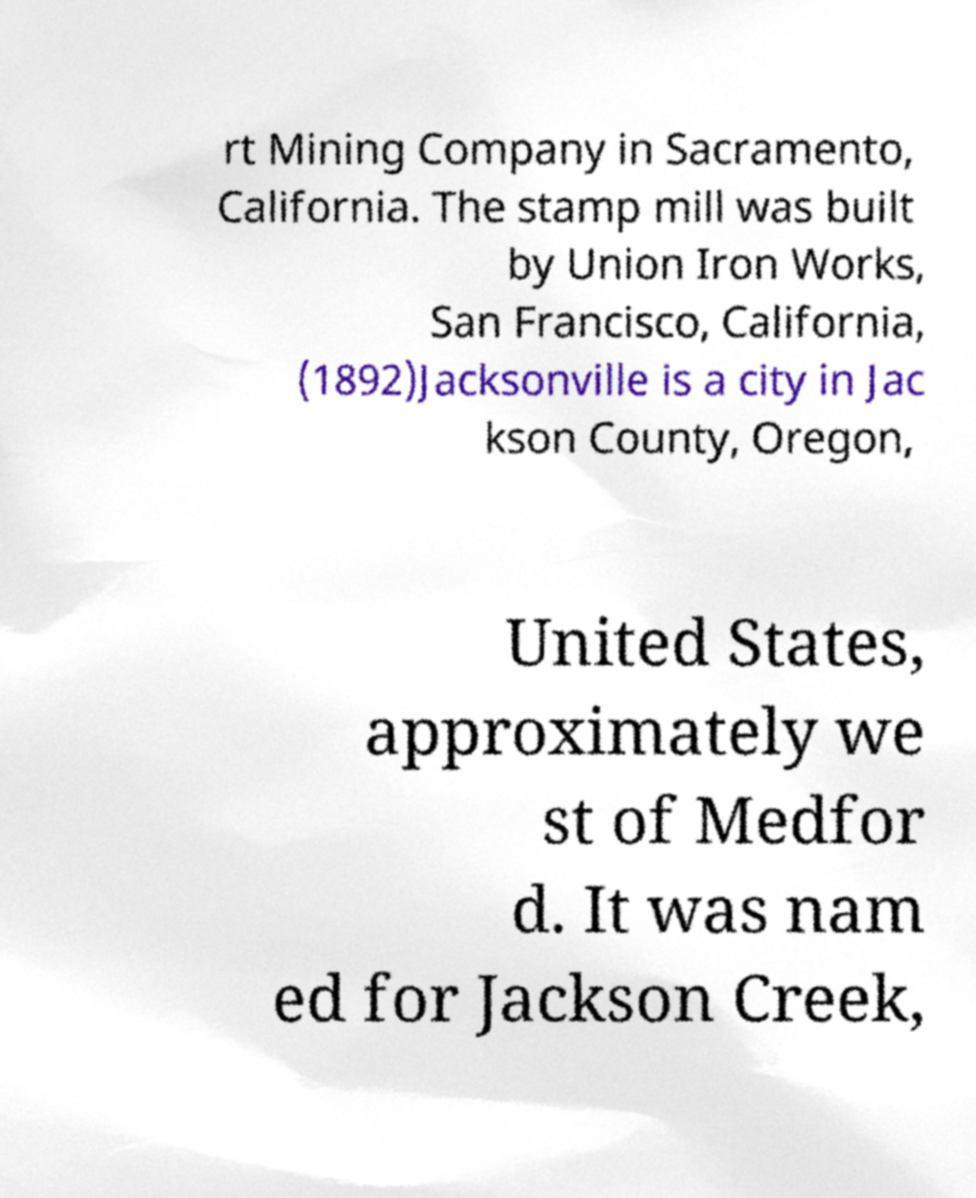Can you read and provide the text displayed in the image?This photo seems to have some interesting text. Can you extract and type it out for me? rt Mining Company in Sacramento, California. The stamp mill was built by Union Iron Works, San Francisco, California, (1892)Jacksonville is a city in Jac kson County, Oregon, United States, approximately we st of Medfor d. It was nam ed for Jackson Creek, 